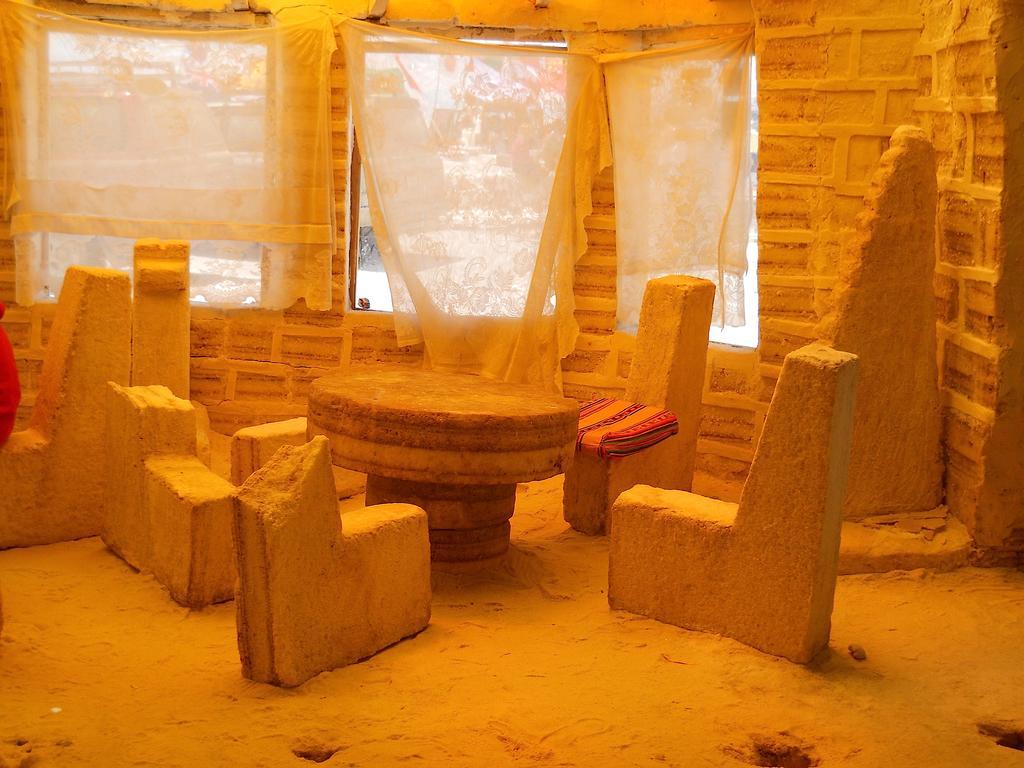Could you give a brief overview of what you see in this image? In this picture I can observe table. There are some stones which are carved into chairs. I can observe curtains and windows. In the background there are trees. 